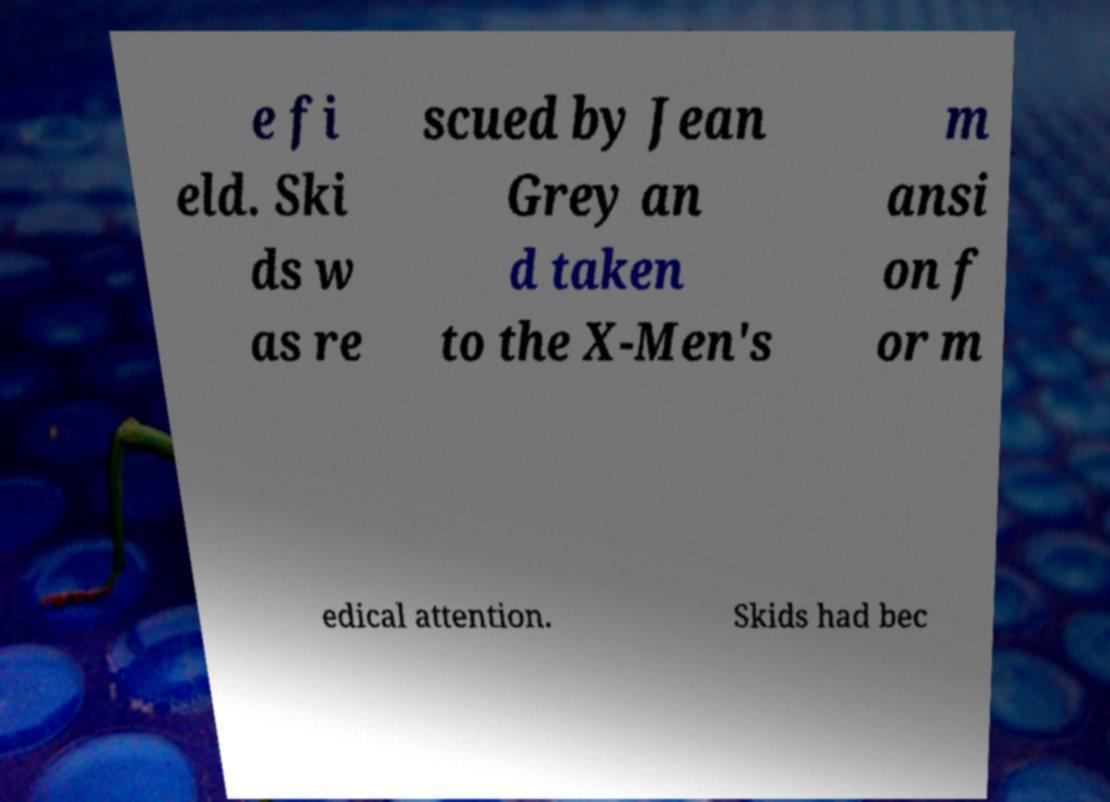Can you accurately transcribe the text from the provided image for me? e fi eld. Ski ds w as re scued by Jean Grey an d taken to the X-Men's m ansi on f or m edical attention. Skids had bec 